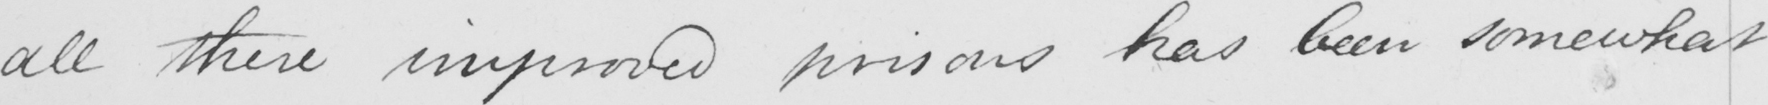Please transcribe the handwritten text in this image. all these improved prisons has been somewhat 